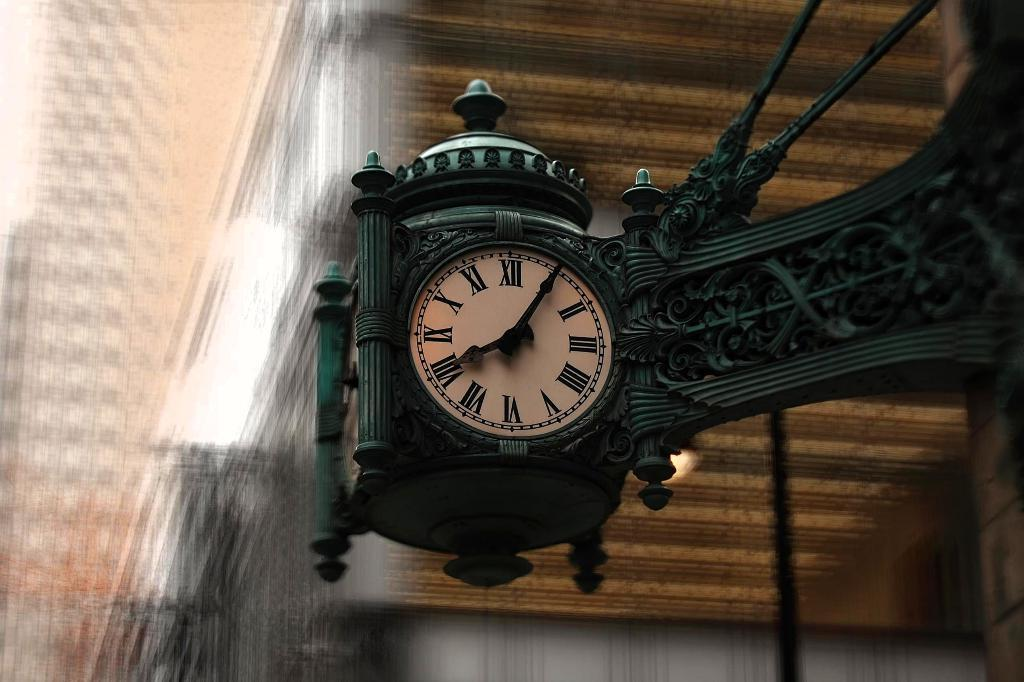<image>
Create a compact narrative representing the image presented. A street hanging green clock shows the time as 08:05 